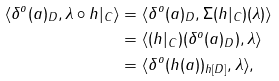<formula> <loc_0><loc_0><loc_500><loc_500>\langle \delta ^ { o } ( a ) _ { D } , \lambda \circ h | _ { C } \rangle & = \langle \delta ^ { o } ( a ) _ { D } , \Sigma ( h | _ { C } ) ( \lambda ) \rangle \\ & = \langle ( h | _ { C } ) ( \delta ^ { o } ( a ) _ { D } ) , \lambda \rangle \\ & = \langle \delta ^ { o } ( h ( a ) ) _ { h [ D ] } , \lambda \rangle ,</formula> 